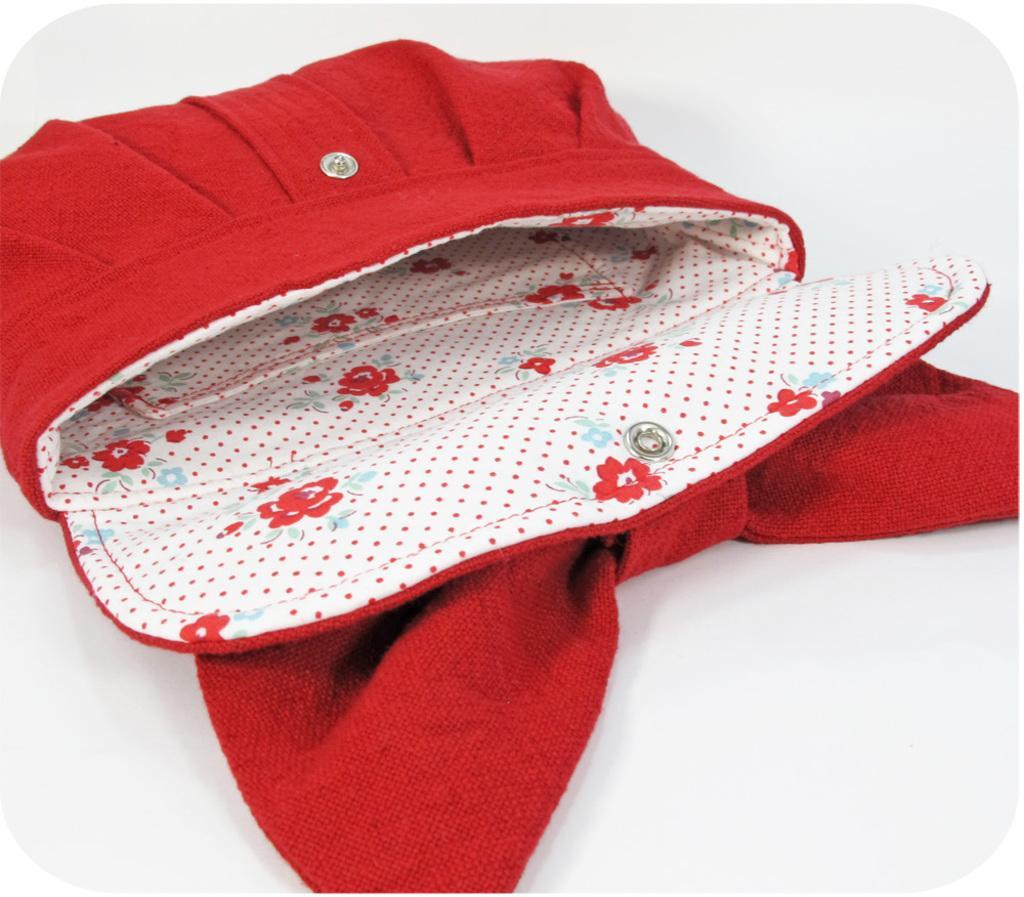Could you give a brief overview of what you see in this image? This picture shows a woman's wallet which is red in colour 